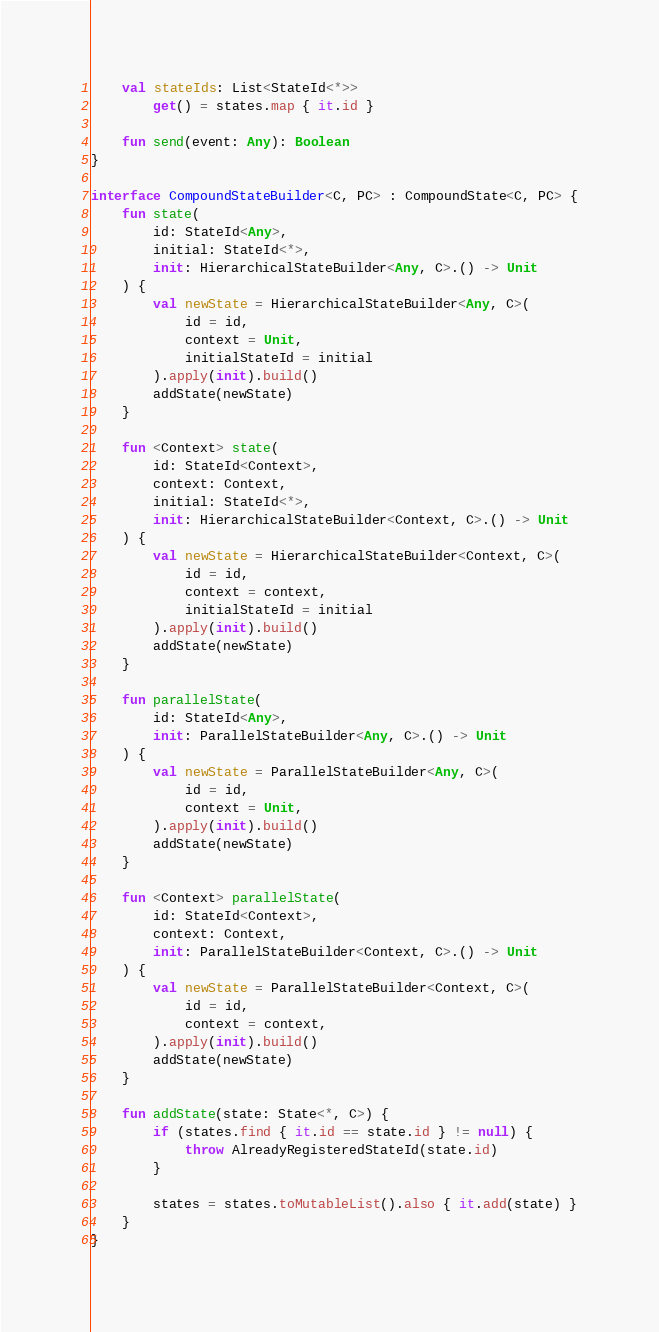Convert code to text. <code><loc_0><loc_0><loc_500><loc_500><_Kotlin_>
    val stateIds: List<StateId<*>>
        get() = states.map { it.id }

    fun send(event: Any): Boolean
}

interface CompoundStateBuilder<C, PC> : CompoundState<C, PC> {
    fun state(
        id: StateId<Any>,
        initial: StateId<*>,
        init: HierarchicalStateBuilder<Any, C>.() -> Unit
    ) {
        val newState = HierarchicalStateBuilder<Any, C>(
            id = id,
            context = Unit,
            initialStateId = initial
        ).apply(init).build()
        addState(newState)
    }

    fun <Context> state(
        id: StateId<Context>,
        context: Context,
        initial: StateId<*>,
        init: HierarchicalStateBuilder<Context, C>.() -> Unit
    ) {
        val newState = HierarchicalStateBuilder<Context, C>(
            id = id,
            context = context,
            initialStateId = initial
        ).apply(init).build()
        addState(newState)
    }

    fun parallelState(
        id: StateId<Any>,
        init: ParallelStateBuilder<Any, C>.() -> Unit
    ) {
        val newState = ParallelStateBuilder<Any, C>(
            id = id,
            context = Unit,
        ).apply(init).build()
        addState(newState)
    }

    fun <Context> parallelState(
        id: StateId<Context>,
        context: Context,
        init: ParallelStateBuilder<Context, C>.() -> Unit
    ) {
        val newState = ParallelStateBuilder<Context, C>(
            id = id,
            context = context,
        ).apply(init).build()
        addState(newState)
    }

    fun addState(state: State<*, C>) {
        if (states.find { it.id == state.id } != null) {
            throw AlreadyRegisteredStateId(state.id)
        }

        states = states.toMutableList().also { it.add(state) }
    }
}
</code> 